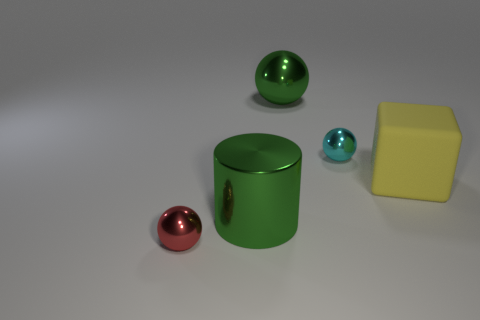Add 5 red metal objects. How many objects exist? 10 Subtract all cubes. How many objects are left? 4 Add 5 green shiny balls. How many green shiny balls are left? 6 Add 3 big yellow cylinders. How many big yellow cylinders exist? 3 Subtract 0 brown balls. How many objects are left? 5 Subtract all large matte spheres. Subtract all big yellow rubber cubes. How many objects are left? 4 